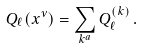<formula> <loc_0><loc_0><loc_500><loc_500>Q _ { \ell } ( x ^ { \nu } ) = \sum _ { k ^ { a } } Q _ { \ell } ^ { ( k ) } \, .</formula> 